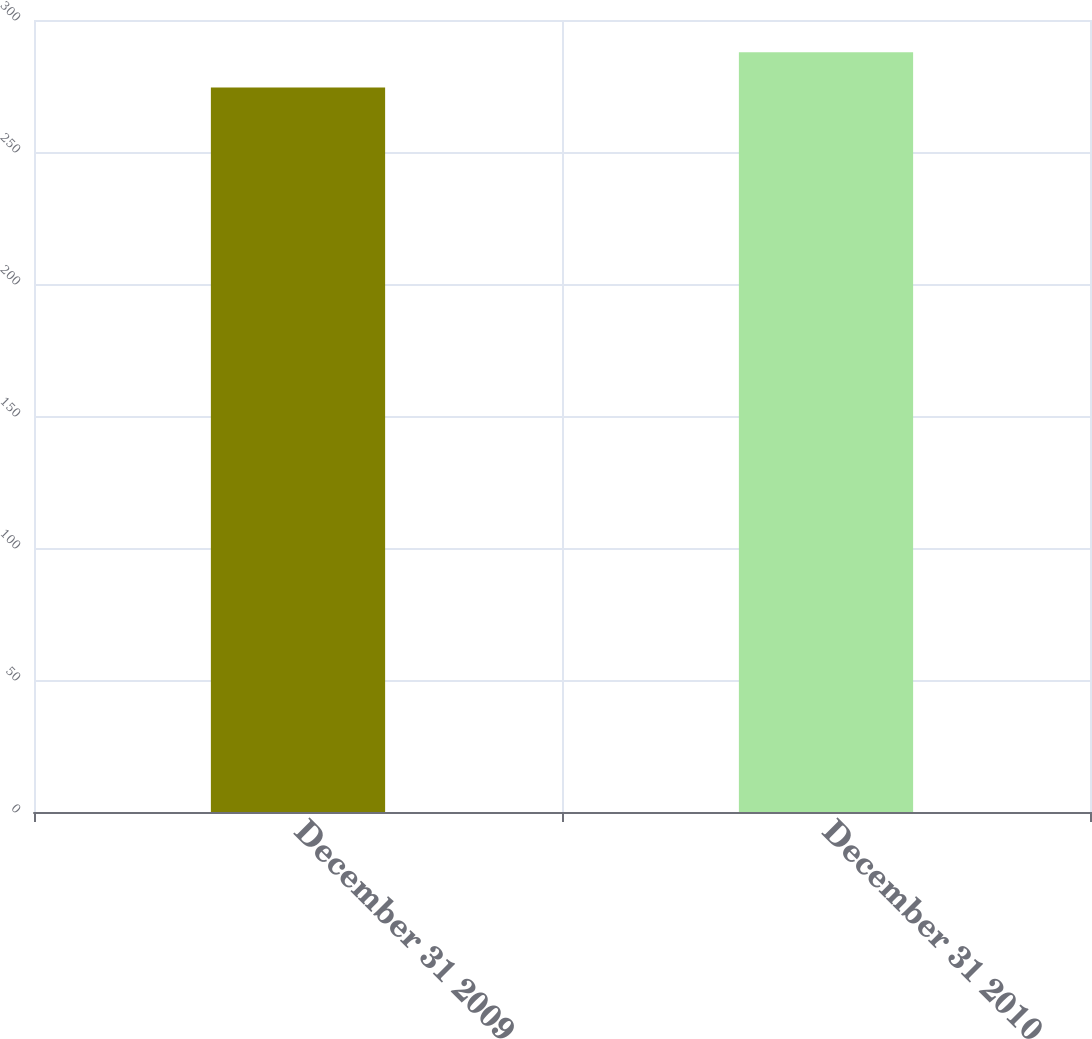<chart> <loc_0><loc_0><loc_500><loc_500><bar_chart><fcel>December 31 2009<fcel>December 31 2010<nl><fcel>274.4<fcel>287.8<nl></chart> 